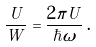<formula> <loc_0><loc_0><loc_500><loc_500>\frac { U } { W } = \frac { 2 \pi U } { \hbar { \omega } } \, .</formula> 